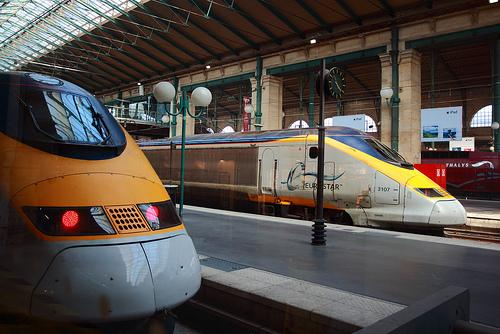Enumerate the different types of objects found in the train station. Clock on a post, lamp posts, windows, train lights, skylight, stone column, metal pole, train company logo, and train identification number. Can you identify the time shown on the clock in the image? The clock reads ten twenty. What is the sentiment or mood conveyed by the image? The image conveys a busy, active, and efficient train station atmosphere. What kind of vehicles are present in the image? Bullet trains with red lights and varying colors such as yellow, white, gray, and orange. Examine the color and design of the metal pole near the green light post. The metal pole is painted green. Explain the appearance of the lamp posts found in the image. The lamp posts are green with white globe lamps, one of which is behind a clock on a post. What is the dominating color scheme of the various objects and structures present in the image? Green, white, yellow, and hints of red from the train lights. Describe the details of the platform in the train station based on the image's description. The platform is a concrete structure at the train station, with green ceiling rafters and a concrete column. Deduce the kind of purpose this train has based on the information provided. This is a very fast train that carries people for transportation. How many train windows are mentioned in the image's information? Five windows on the bullet train. Can you find the lost luggage lying unattended on the platform? This question directly asks for something that doesn't exist in the image. Notice the conductor in his uniform, standing next to the train's entrance. There is no conductor mentioned or visible in the image, but this declarative sentence describes an expected scene at a train station. Observe the beautiful sunset through the train windows, casting a warm glow over the scene. No, it's not mentioned in the image. Where are the passengers waiting in line to board the train? This question asks for the location of the passengers, who are not present in the image. Find the graffiti on the side of the train, which says "All aboard!" This instruction is an explicit command to find a specific detail, but there is no graffiti mentioned or visible in the image. Can you spot the blue umbrella near the waiting area on the platform? There is no blue umbrella in the image, but the instruction suggests looking for one in the waiting area. 